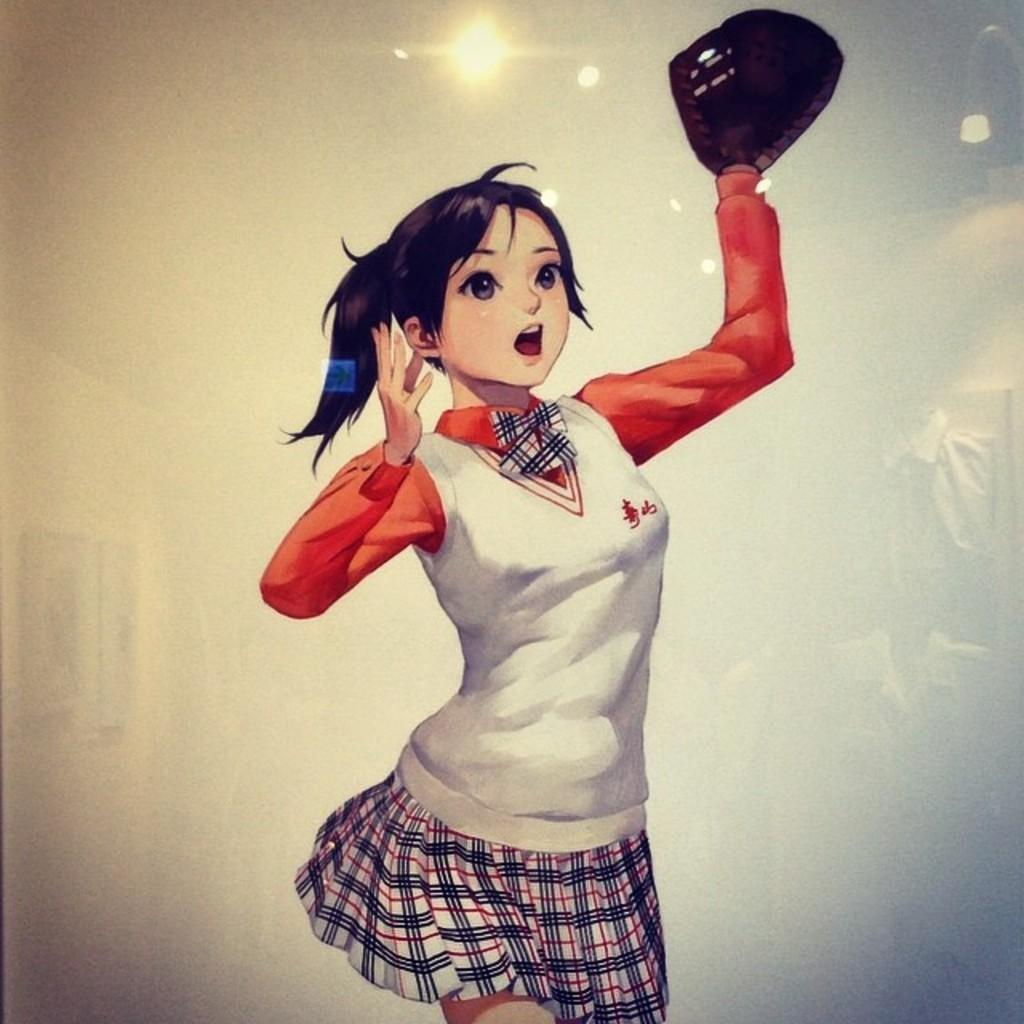Who is present in the image? There is a woman in the image. What is the woman holding in the image? The woman is holding an object. What can be seen on the wall in the image? There are photo frames on a wall in the image. What is visible in the image that provides light? There are lights visible in the image. How many rabbits are hopping around the woman in the image? There are no rabbits present in the image. What type of egg is being cooked on the flame in the image? There is no egg or flame present in the image. 